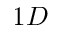Convert formula to latex. <formula><loc_0><loc_0><loc_500><loc_500>1 D</formula> 